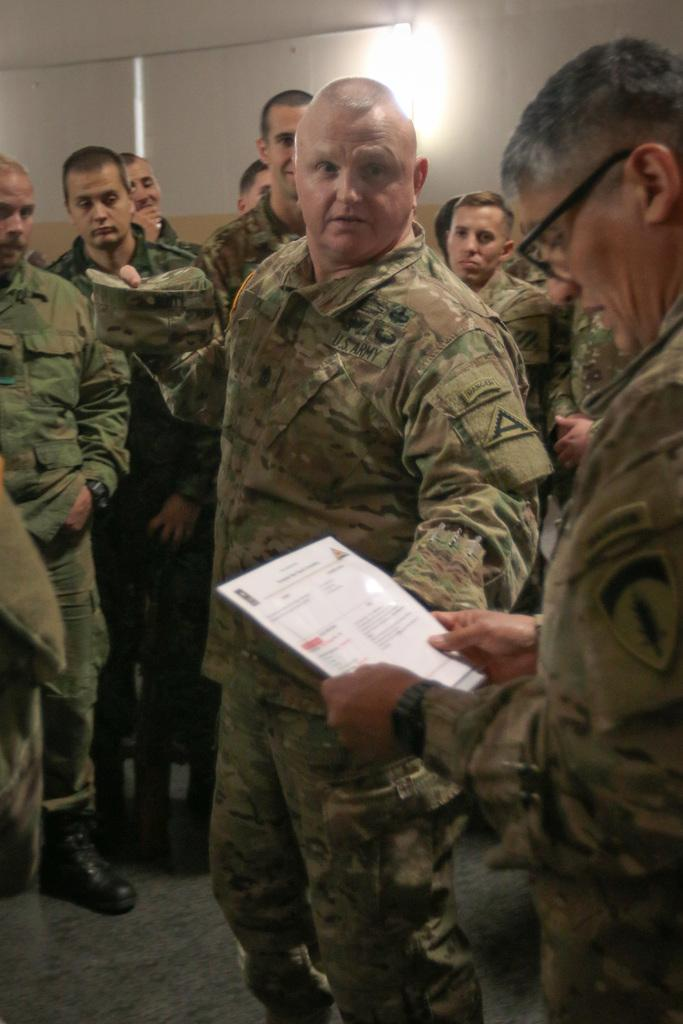What are the people in the image doing? There are persons standing on the floor in the image. Can you describe the man on the right side of the image? A man is holding a paper in his hands on the right side of the image. What can be seen on the wall in the background of the image? There is a light on the wall in the background of the image. What force is causing the paper to levitate in the image? There is no force causing the paper to levitate in the image; the man is holding it in his hands. What caption would you give to the image? The image does not have a caption, as it is a still photograph. 